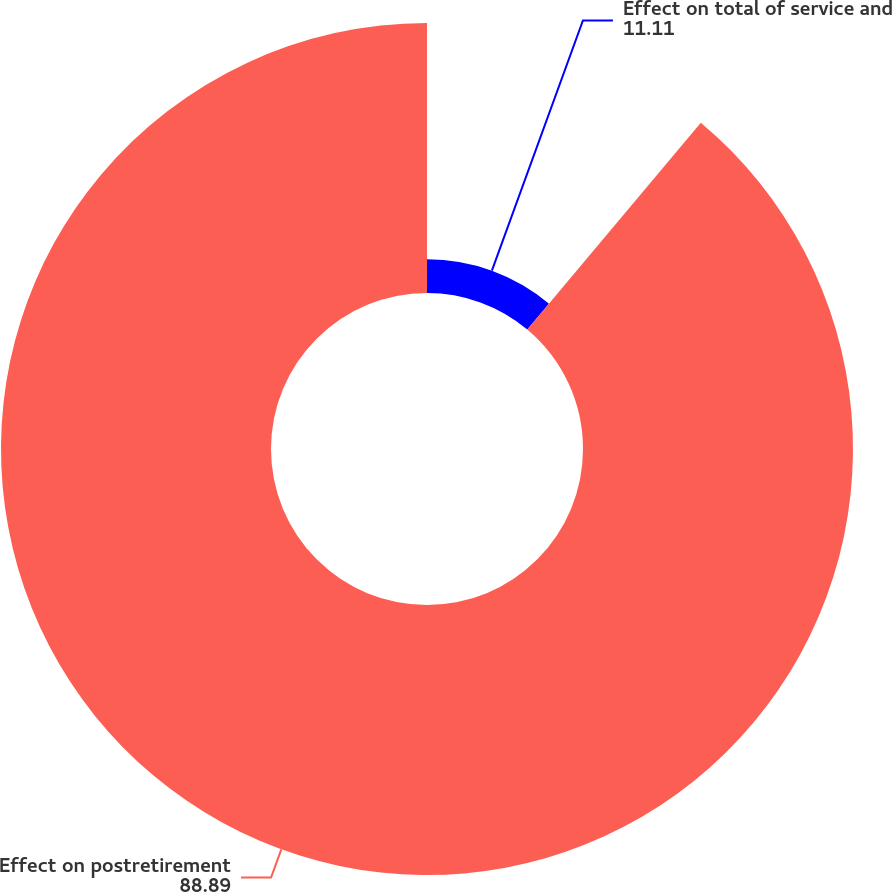Convert chart to OTSL. <chart><loc_0><loc_0><loc_500><loc_500><pie_chart><fcel>Effect on total of service and<fcel>Effect on postretirement<nl><fcel>11.11%<fcel>88.89%<nl></chart> 